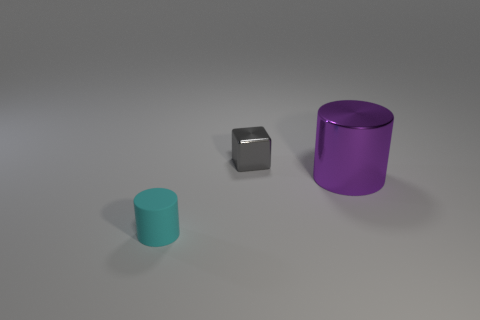Do the small object on the right side of the tiny cylinder and the metallic object that is in front of the gray object have the same shape?
Provide a succinct answer. No. There is a gray object that is the same size as the cyan matte cylinder; what material is it?
Keep it short and to the point. Metal. Do the object on the left side of the gray thing and the thing that is to the right of the small gray shiny block have the same material?
Your response must be concise. No. What shape is the matte thing that is the same size as the gray metal block?
Provide a short and direct response. Cylinder. How many other things are there of the same color as the small rubber cylinder?
Offer a terse response. 0. There is a tiny cylinder that is in front of the large purple metal cylinder; what is its color?
Your response must be concise. Cyan. How many other objects are the same material as the cyan thing?
Offer a terse response. 0. Are there more rubber things behind the shiny cylinder than tiny gray cubes on the left side of the gray metallic thing?
Give a very brief answer. No. How many things are in front of the shiny cylinder?
Provide a short and direct response. 1. Do the cyan cylinder and the tiny thing that is behind the big metallic cylinder have the same material?
Your answer should be compact. No. 